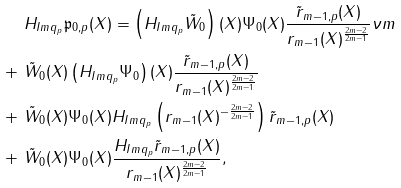Convert formula to latex. <formula><loc_0><loc_0><loc_500><loc_500>& \ H _ { I m q _ { p } } \mathfrak { p } _ { 0 , p } ( X ) = \left ( H _ { I m q _ { p } } \tilde { W } _ { 0 } \right ) ( X ) \Psi _ { 0 } ( X ) \frac { \tilde { r } _ { m - 1 , p } ( X ) } { r _ { m - 1 } ( X ) ^ { \frac { 2 m - 2 } { 2 m - 1 } } } \nu m \\ + & \ \tilde { W } _ { 0 } ( X ) \left ( H _ { I m q _ { p } } \Psi _ { 0 } \right ) ( X ) \frac { \tilde { r } _ { m - 1 , p } ( X ) } { r _ { m - 1 } ( X ) ^ { \frac { 2 m - 2 } { 2 m - 1 } } } \\ + & \ \tilde { W } _ { 0 } ( X ) \Psi _ { 0 } ( X ) H _ { I m q _ { p } } \left ( r _ { m - 1 } ( X ) ^ { - \frac { 2 m - 2 } { 2 m - 1 } } \right ) \tilde { r } _ { m - 1 , p } ( X ) \\ + & \ \tilde { W } _ { 0 } ( X ) \Psi _ { 0 } ( X ) \frac { H _ { I m q _ { p } } \tilde { r } _ { m - 1 , p } ( X ) } { r _ { m - 1 } ( X ) ^ { \frac { 2 m - 2 } { 2 m - 1 } } } ,</formula> 